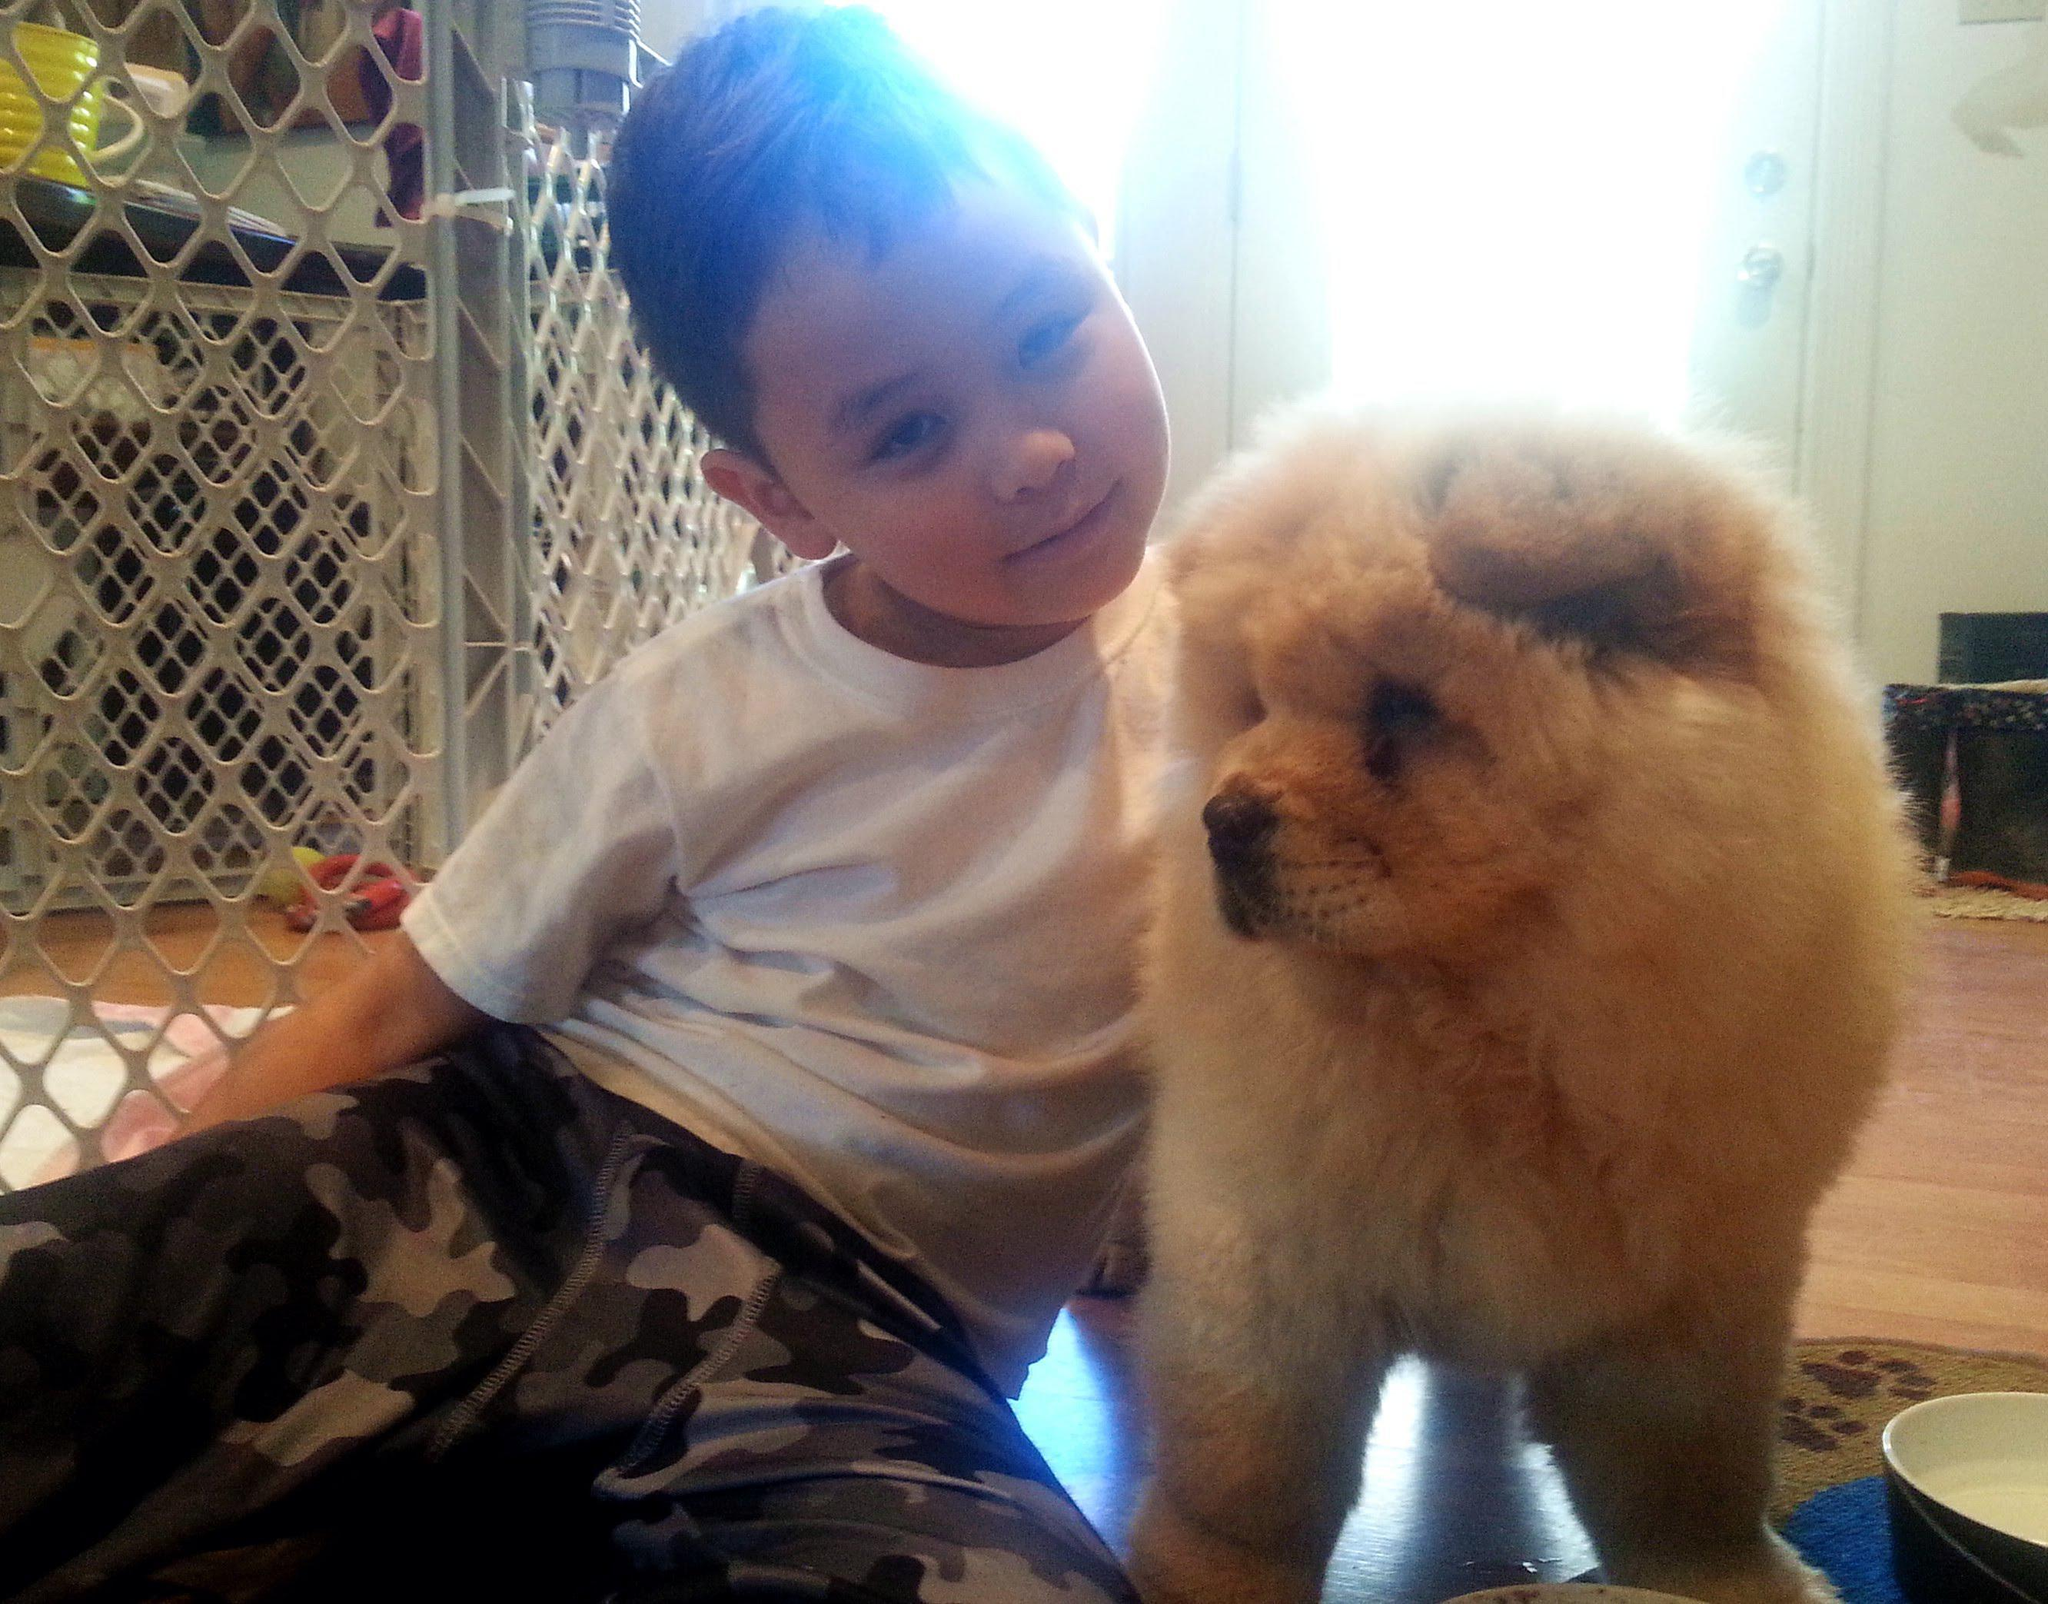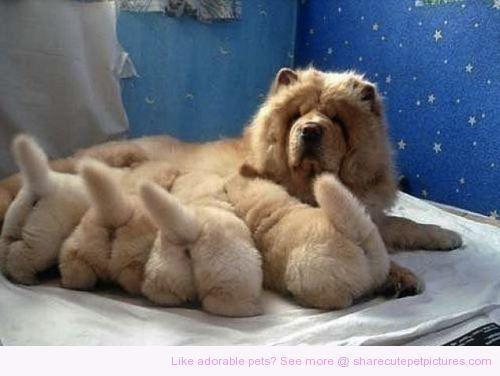The first image is the image on the left, the second image is the image on the right. Examine the images to the left and right. Is the description "The right image shows a baby sitting to the right of an adult chow, and the left image shows one forward-turned cream-colored chow puppy." accurate? Answer yes or no. No. The first image is the image on the left, the second image is the image on the right. Examine the images to the left and right. Is the description "The left and right image contains the same number of dog and on the right image there is a child." accurate? Answer yes or no. No. 